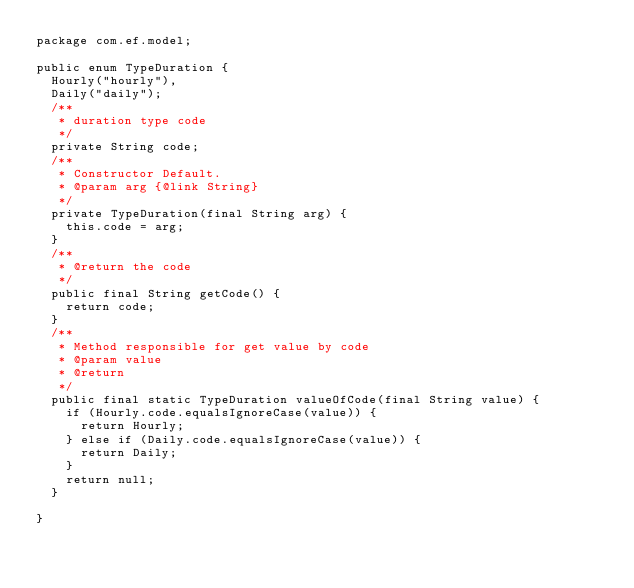Convert code to text. <code><loc_0><loc_0><loc_500><loc_500><_Java_>package com.ef.model;

public enum TypeDuration {
	Hourly("hourly"),
	Daily("daily");
	/**
	 * duration type code
	 */
	private String code;
	/**
	 * Constructor Default. 
	 * @param arg {@link String}
	 */
	private TypeDuration(final String arg) {
		this.code = arg;
	}
	/**
	 * @return the code
	 */
	public final String getCode() {
		return code;
	}
	/**
	 * Method responsible for get value by code
	 * @param value
	 * @return
	 */
	public final static TypeDuration valueOfCode(final String value) {
		if (Hourly.code.equalsIgnoreCase(value)) {
			return Hourly;
		} else if (Daily.code.equalsIgnoreCase(value)) {
			return Daily;
		}
		return null;
	}
	
}
</code> 